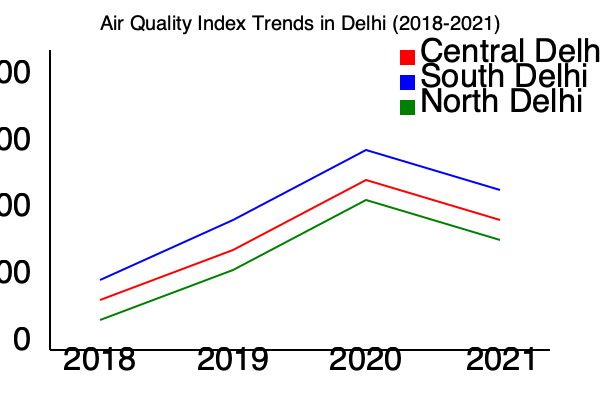Based on the line graph showing Air Quality Index (AQI) trends in different areas of Delhi from 2018 to 2021, which area consistently had the lowest AQI values, and what does this indicate about air quality in that region compared to others? To answer this question, we need to analyze the graph step-by-step:

1. The graph shows AQI trends for three areas of Delhi: Central Delhi (red line), South Delhi (blue line), and North Delhi (green line).

2. Lower AQI values indicate better air quality, while higher values indicate worse air quality.

3. Examining the lines for each year:
   - 2018: South Delhi has the lowest point
   - 2019: South Delhi has the lowest point
   - 2020: South Delhi has the lowest point
   - 2021: South Delhi has the lowest point

4. We can observe that the blue line (South Delhi) consistently remains below the other two lines throughout the entire period from 2018 to 2021.

5. This consistent lower position of the South Delhi line indicates that it had the lowest AQI values among the three areas for all four years.

6. Lower AQI values signify better air quality. Therefore, South Delhi consistently had better air quality compared to Central and North Delhi during this period.
Answer: South Delhi; it had consistently better air quality. 